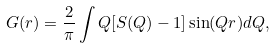<formula> <loc_0><loc_0><loc_500><loc_500>G ( r ) = \frac { 2 } { \pi } \int Q [ S ( Q ) - 1 ] \sin ( Q r ) d Q ,</formula> 